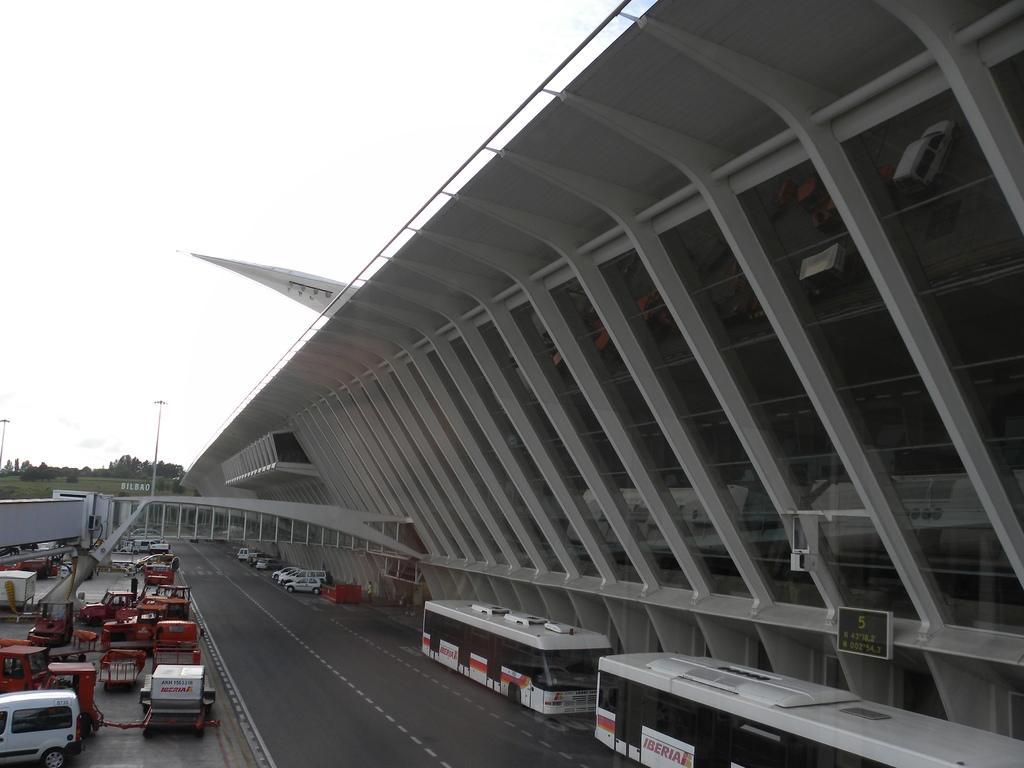Please provide a concise description of this image. In the image there is road in the middle with buses and vehicles on either side of it, right side its a building and above its sky. 